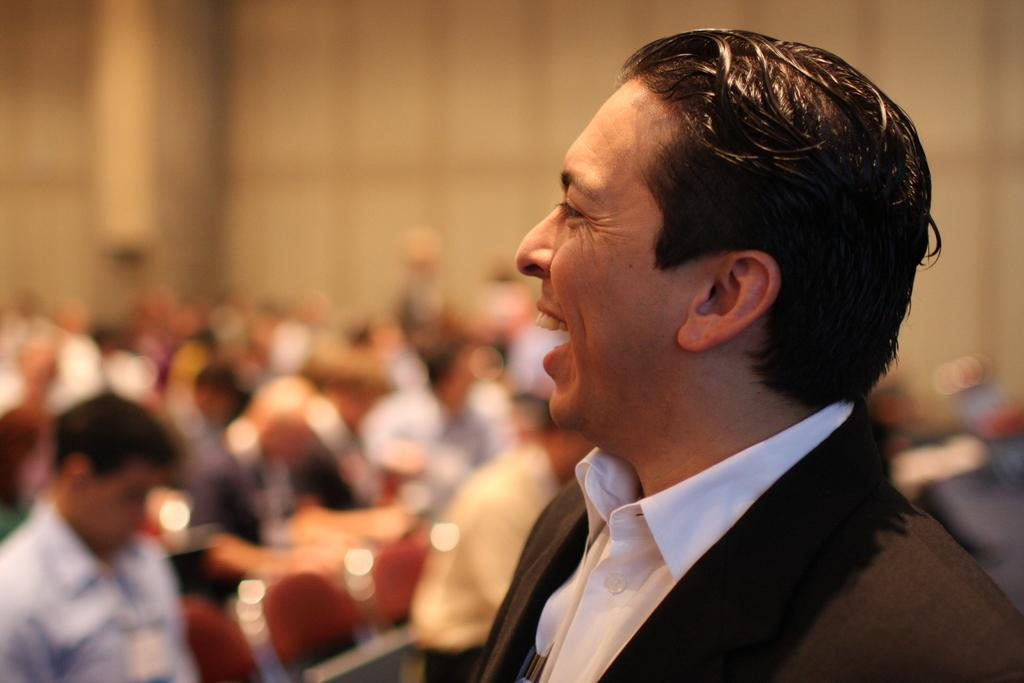What is the person in the image wearing? The person in the image is wearing a suit. What is the facial expression of the person? The person is smiling. In which direction is the person looking? The person is looking towards the left side. Can you describe the background of the image? The background has a blurred view. How many people are present in the image? There is a group of people in the image. What type of chicken can be seen in the crate in the image? There is no chicken or crate present in the image. 